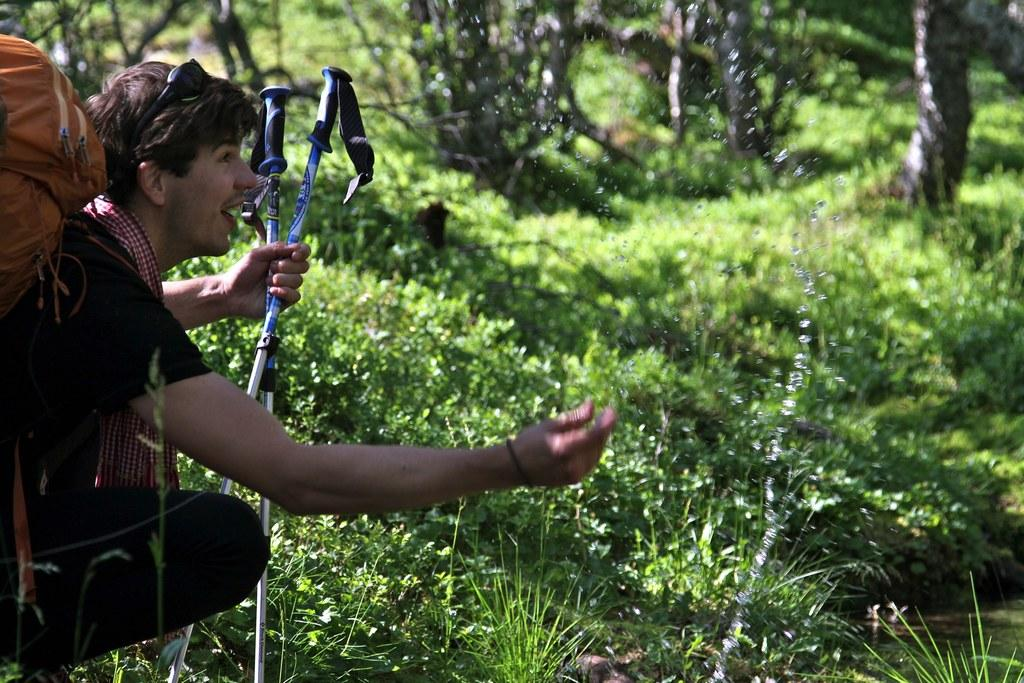Who is present in the image? There is a man in the image. Where is the man located in the image? The man is sitting at the left side. What is the man holding in the image? The man is holding ski sticks. What can be seen in the background of the image? There is grass and trees in the backdrop of the image. What type of pipe is the man smoking in the image? There is no pipe present in the image; the man is holding ski sticks. What team is the man representing in the image? There is no indication of a team in the image; it only shows a man sitting with ski sticks. 